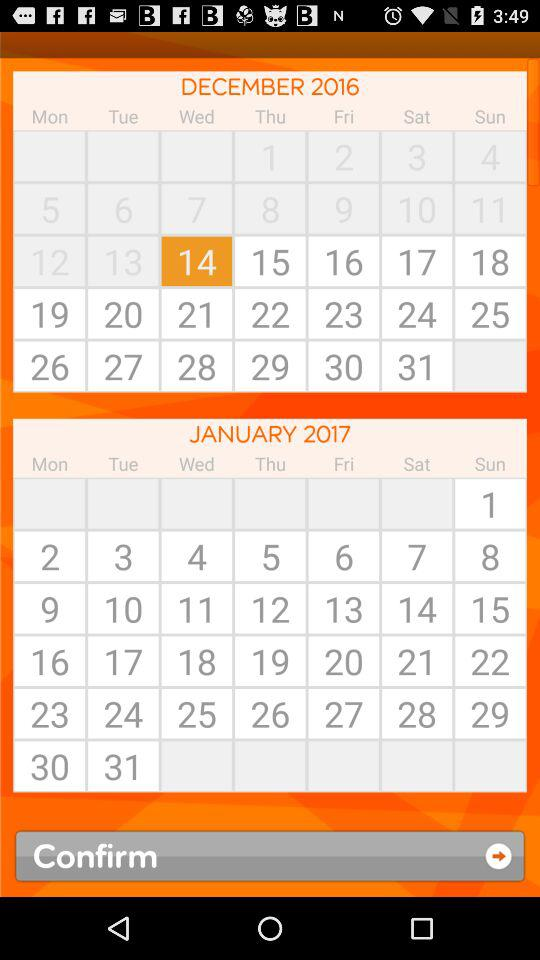Which day is displayed on the calendar on December 14th? The day is Wednesday. 